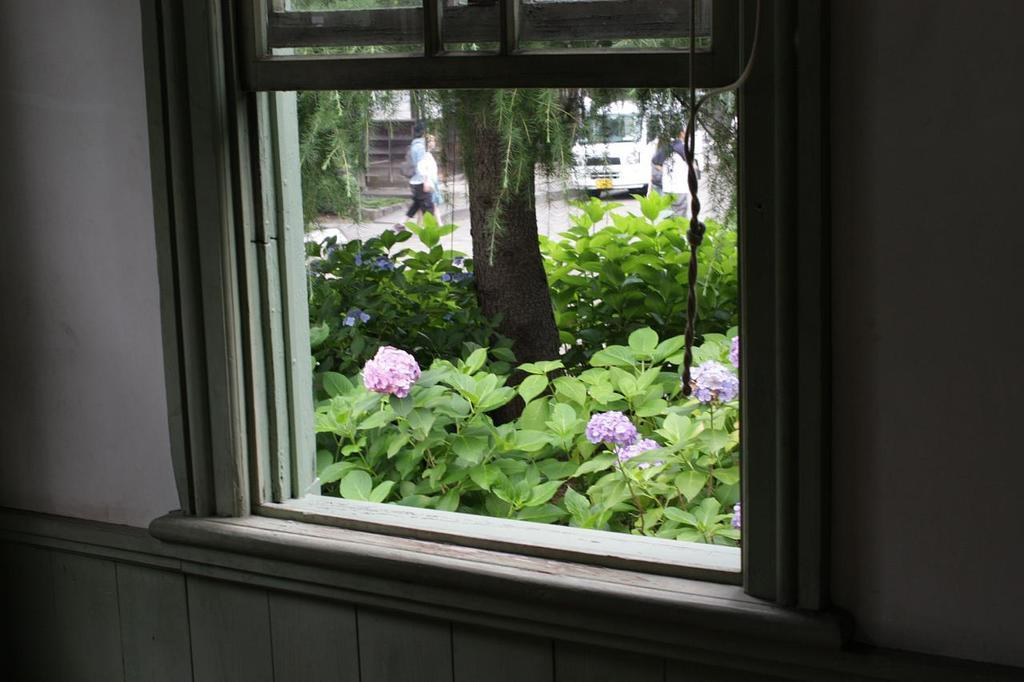What type of structure can be seen in the image? There is a wall in the image. What feature is present in the wall? There is a window in the image. What can be seen through the window? Plants, flowers, trees, people, and a vehicle are visible through the window. What type of jelly can be seen on the wall in the image? There is no jelly present on the wall in the image. Can you describe the seashore visible through the window in the image? There is no seashore visible through the window in the image; only plants, flowers, trees, people, and a vehicle can be seen. 